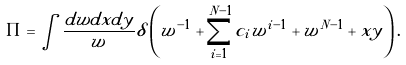<formula> <loc_0><loc_0><loc_500><loc_500>\Pi = \int \frac { d w d x d y } { w } \delta \left ( w ^ { - 1 } + \sum _ { i = 1 } ^ { N - 1 } c _ { i } w ^ { i - 1 } + w ^ { N - 1 } + x y \right ) .</formula> 